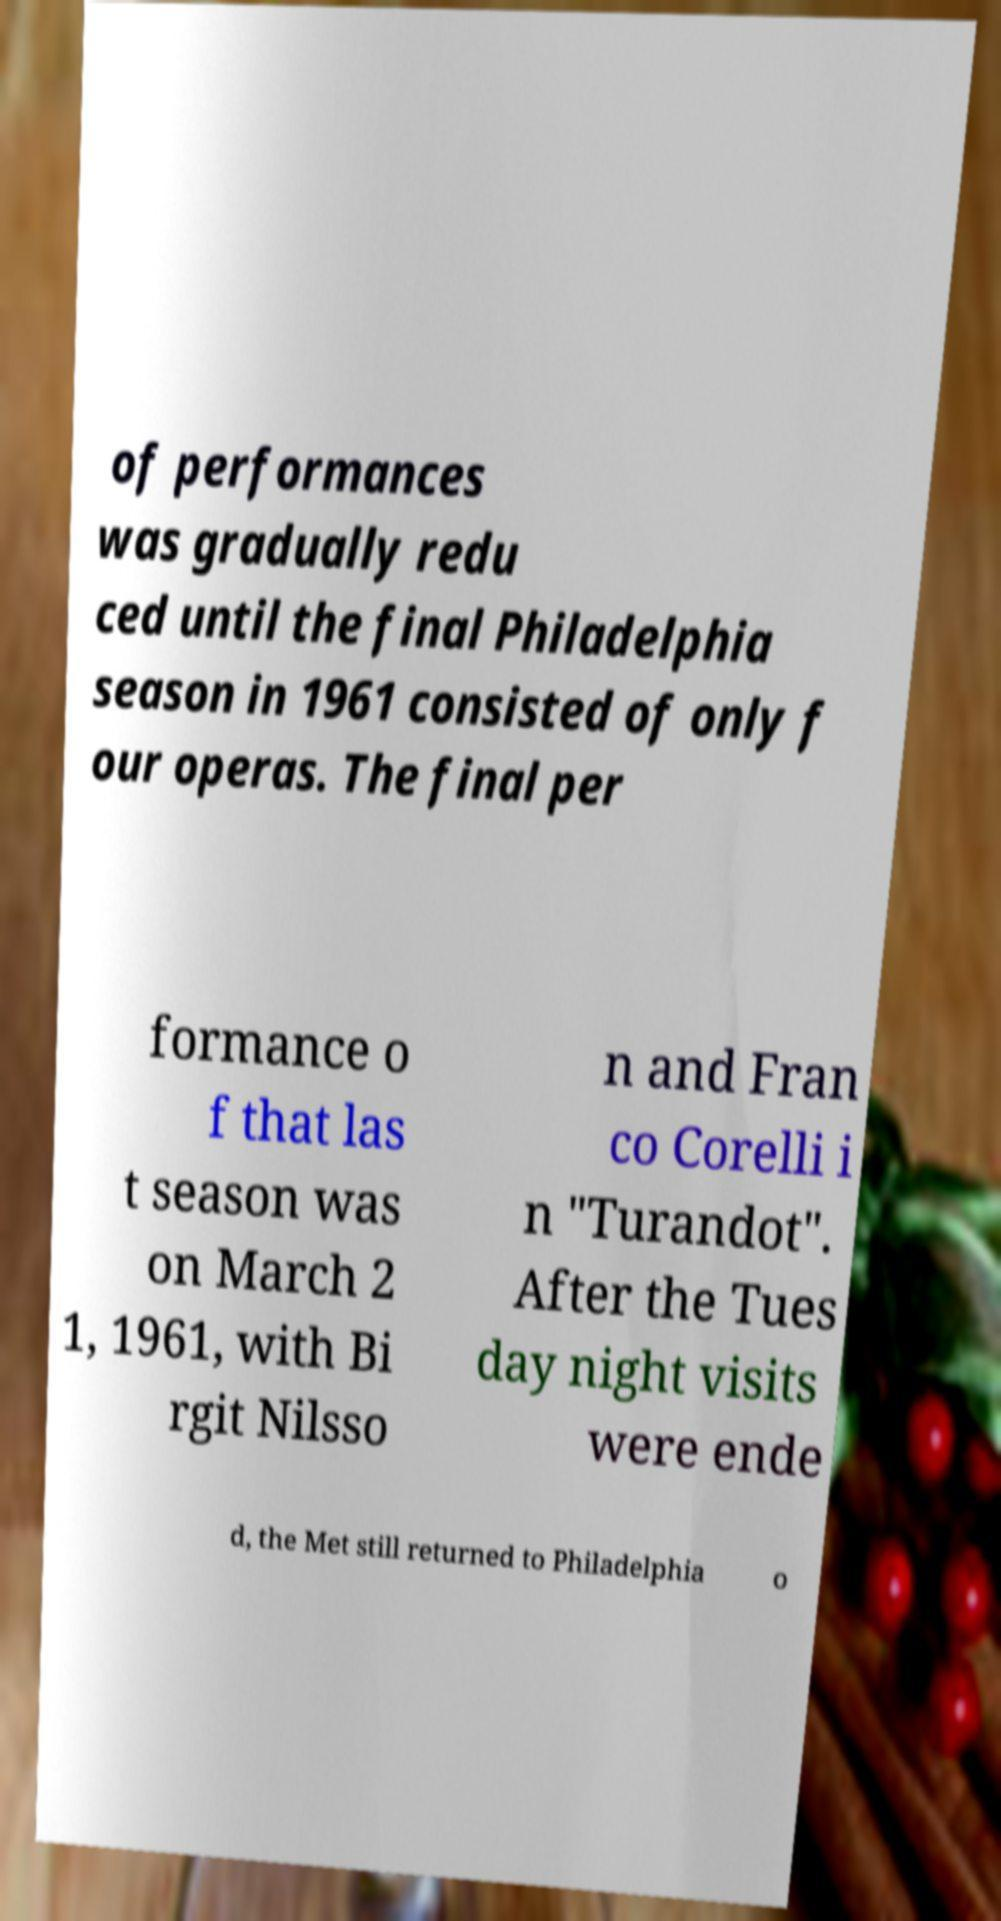I need the written content from this picture converted into text. Can you do that? of performances was gradually redu ced until the final Philadelphia season in 1961 consisted of only f our operas. The final per formance o f that las t season was on March 2 1, 1961, with Bi rgit Nilsso n and Fran co Corelli i n "Turandot". After the Tues day night visits were ende d, the Met still returned to Philadelphia o 